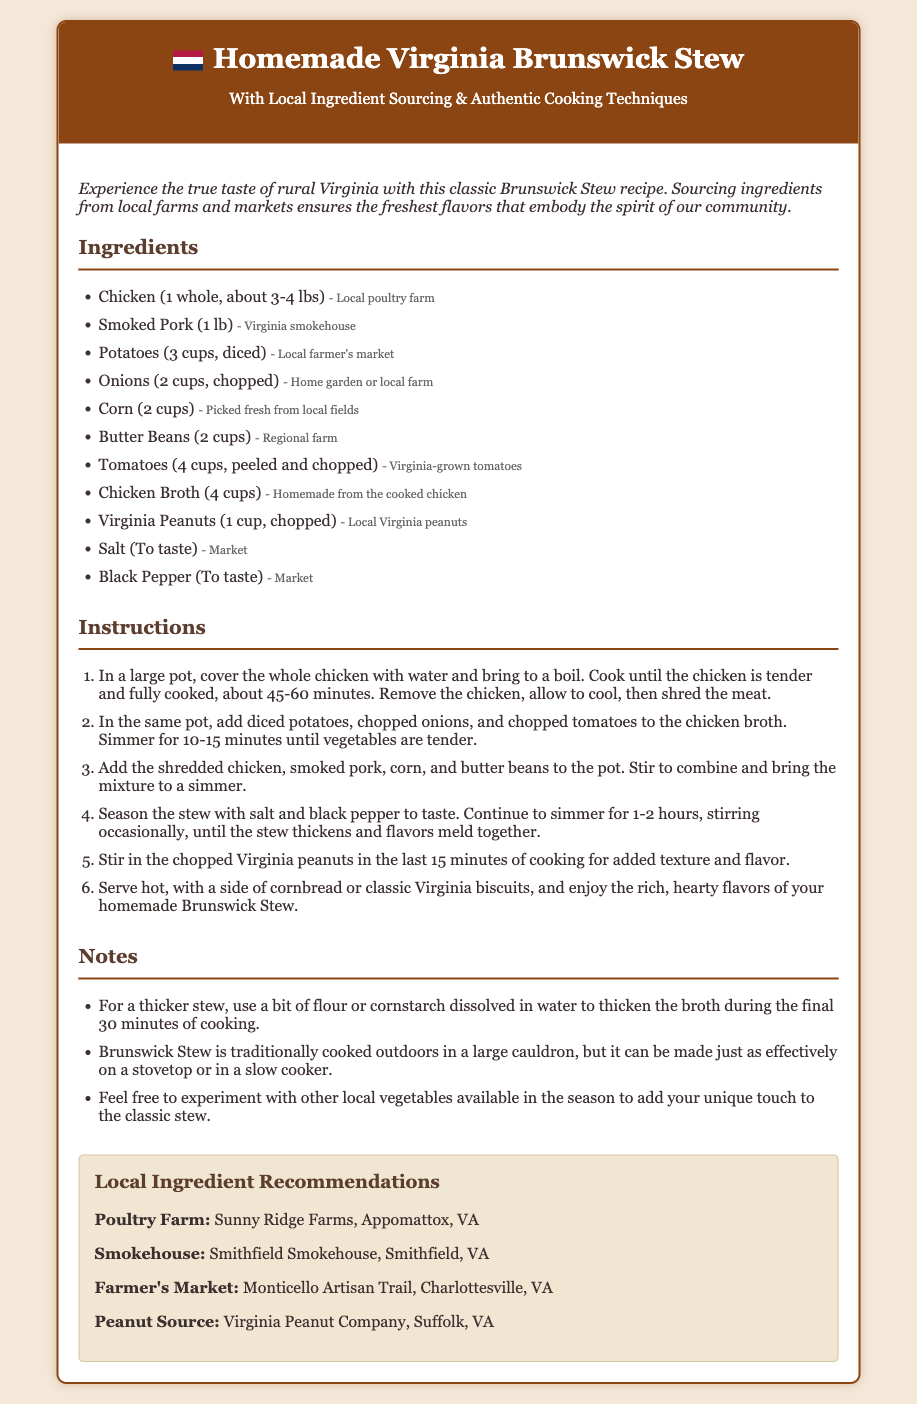What is the main dish featured in the recipe? The recipe focuses on a traditional and classic dish from Virginia known as Brunswick Stew.
Answer: Brunswick Stew How many cups of corn are needed for the recipe? The recipe specifies that 2 cups of corn are required for making the stew.
Answer: 2 cups What local farm is recommended for chicken sourcing? The recommended local poultry farm for sourcing chicken is mentioned in the document.
Answer: Sunny Ridge Farms What is the cooking time for the chicken? The document states that the chicken should be cooked for about 45-60 minutes until tender.
Answer: 45-60 minutes Which ingredient is added in the last 15 minutes of cooking? The recipe notes that chopped Virginia peanuts are added towards the end of the cooking process for flavor and texture.
Answer: Virginia peanuts How long should the stew be simmered once all ingredients are added? The instructions specify that the stew should continue to simmer for 1-2 hours after adding the other ingredients.
Answer: 1-2 hours What is stated as a way to thicken the stew? The notes suggest that flour or cornstarch dissolved in water can be used to thicken the stew.
Answer: Flour or cornstarch Where can you find locally-sourced Virginia peanuts? The document provides a local recommendation for sourcing Virginia peanuts.
Answer: Virginia Peanut Company 